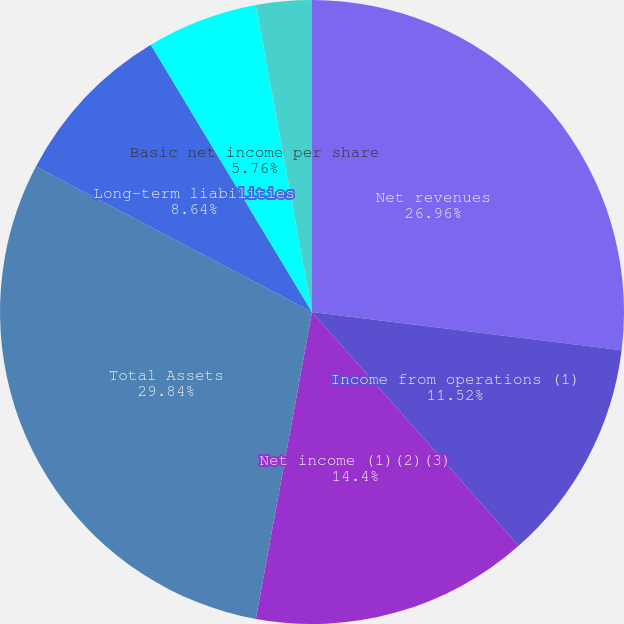<chart> <loc_0><loc_0><loc_500><loc_500><pie_chart><fcel>Net revenues<fcel>Income from operations (1)<fcel>Net income (1)(2)(3)<fcel>Total Assets<fcel>Long-term liabilities<fcel>Basic net income per share<fcel>Diluted net income per share<fcel>Dividends paid per share<nl><fcel>26.95%<fcel>11.52%<fcel>14.4%<fcel>29.83%<fcel>8.64%<fcel>5.76%<fcel>2.88%<fcel>0.0%<nl></chart> 